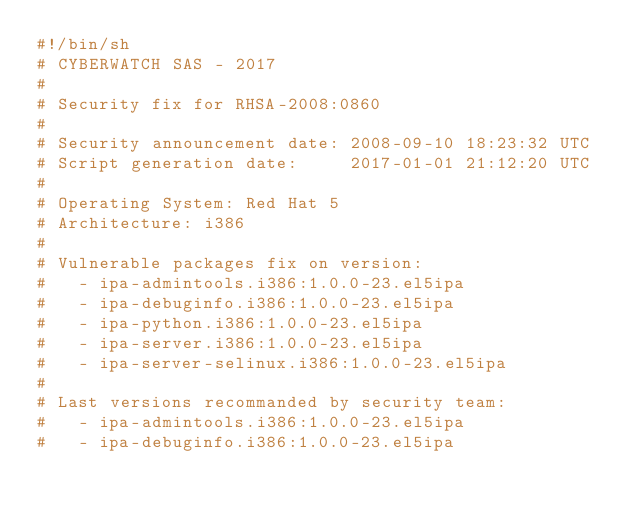Convert code to text. <code><loc_0><loc_0><loc_500><loc_500><_Bash_>#!/bin/sh
# CYBERWATCH SAS - 2017
#
# Security fix for RHSA-2008:0860
#
# Security announcement date: 2008-09-10 18:23:32 UTC
# Script generation date:     2017-01-01 21:12:20 UTC
#
# Operating System: Red Hat 5
# Architecture: i386
#
# Vulnerable packages fix on version:
#   - ipa-admintools.i386:1.0.0-23.el5ipa
#   - ipa-debuginfo.i386:1.0.0-23.el5ipa
#   - ipa-python.i386:1.0.0-23.el5ipa
#   - ipa-server.i386:1.0.0-23.el5ipa
#   - ipa-server-selinux.i386:1.0.0-23.el5ipa
#
# Last versions recommanded by security team:
#   - ipa-admintools.i386:1.0.0-23.el5ipa
#   - ipa-debuginfo.i386:1.0.0-23.el5ipa</code> 